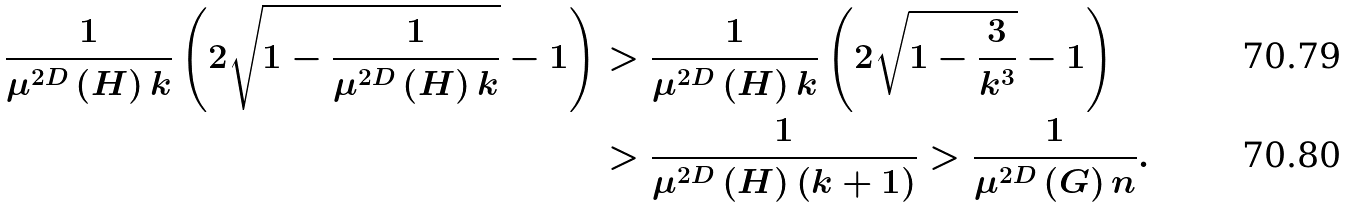Convert formula to latex. <formula><loc_0><loc_0><loc_500><loc_500>\frac { 1 } { \mu ^ { 2 D } \left ( H \right ) k } \left ( 2 \sqrt { 1 - \frac { 1 } { \mu ^ { 2 D } \left ( H \right ) k } } - 1 \right ) & > \frac { 1 } { \mu ^ { 2 D } \left ( H \right ) k } \left ( 2 \sqrt { 1 - \frac { 3 } { k ^ { 3 } } } - 1 \right ) \\ & > \frac { 1 } { \mu ^ { 2 D } \left ( H \right ) \left ( k + 1 \right ) } > \frac { 1 } { \mu ^ { 2 D } \left ( G \right ) n } .</formula> 